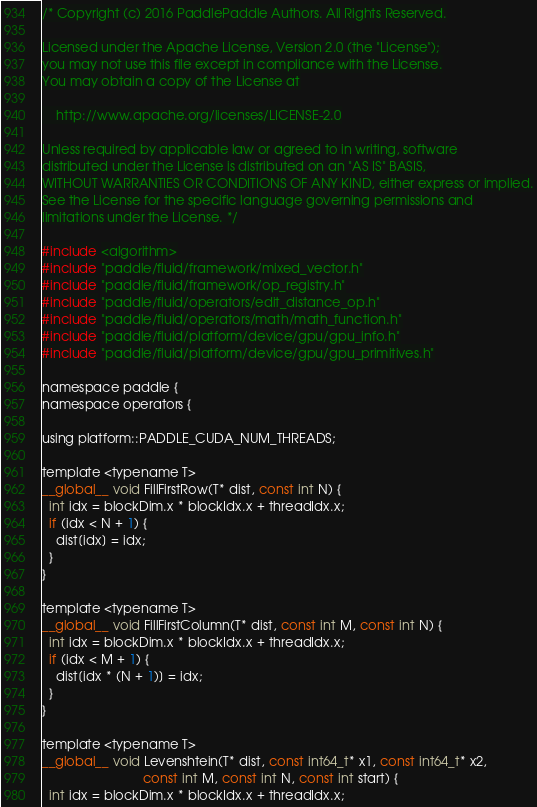Convert code to text. <code><loc_0><loc_0><loc_500><loc_500><_Cuda_>/* Copyright (c) 2016 PaddlePaddle Authors. All Rights Reserved.

Licensed under the Apache License, Version 2.0 (the "License");
you may not use this file except in compliance with the License.
You may obtain a copy of the License at

    http://www.apache.org/licenses/LICENSE-2.0

Unless required by applicable law or agreed to in writing, software
distributed under the License is distributed on an "AS IS" BASIS,
WITHOUT WARRANTIES OR CONDITIONS OF ANY KIND, either express or implied.
See the License for the specific language governing permissions and
limitations under the License. */

#include <algorithm>
#include "paddle/fluid/framework/mixed_vector.h"
#include "paddle/fluid/framework/op_registry.h"
#include "paddle/fluid/operators/edit_distance_op.h"
#include "paddle/fluid/operators/math/math_function.h"
#include "paddle/fluid/platform/device/gpu/gpu_info.h"
#include "paddle/fluid/platform/device/gpu/gpu_primitives.h"

namespace paddle {
namespace operators {

using platform::PADDLE_CUDA_NUM_THREADS;

template <typename T>
__global__ void FillFirstRow(T* dist, const int N) {
  int idx = blockDim.x * blockIdx.x + threadIdx.x;
  if (idx < N + 1) {
    dist[idx] = idx;
  }
}

template <typename T>
__global__ void FillFirstColumn(T* dist, const int M, const int N) {
  int idx = blockDim.x * blockIdx.x + threadIdx.x;
  if (idx < M + 1) {
    dist[idx * (N + 1)] = idx;
  }
}

template <typename T>
__global__ void Levenshtein(T* dist, const int64_t* x1, const int64_t* x2,
                            const int M, const int N, const int start) {
  int idx = blockDim.x * blockIdx.x + threadIdx.x;</code> 